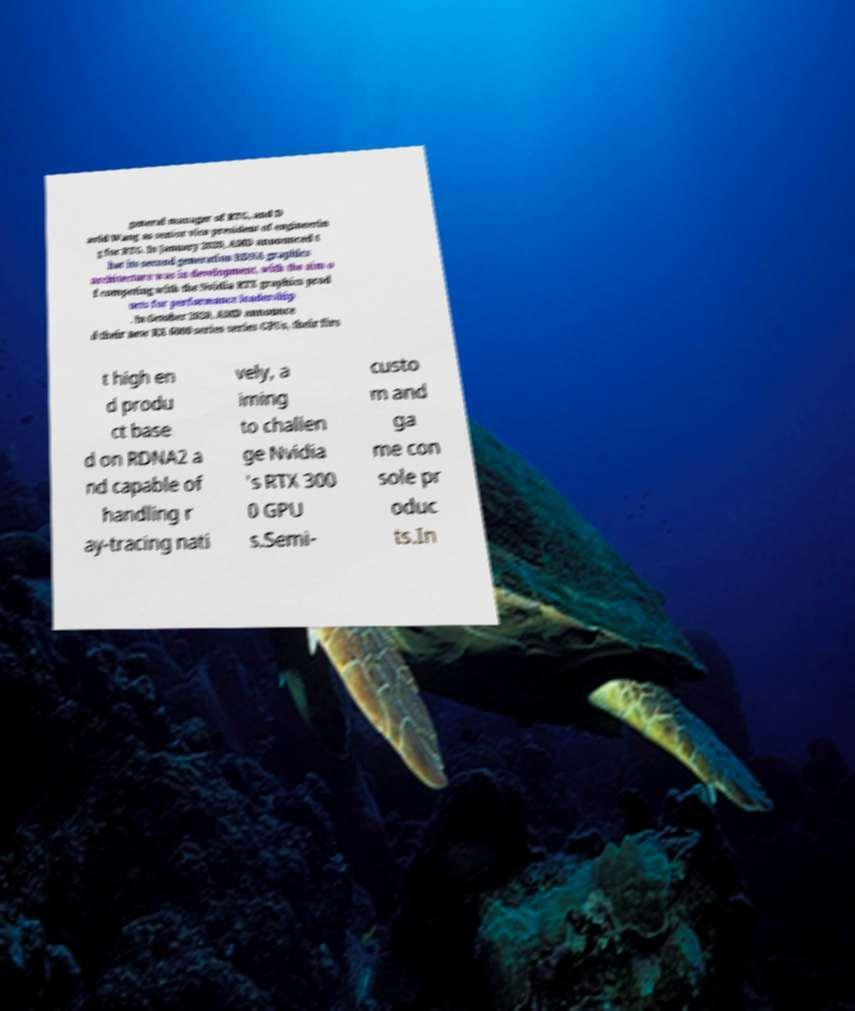Could you assist in decoding the text presented in this image and type it out clearly? general manager of RTG, and D avid Wang as senior vice president of engineerin g for RTG. In January 2020, AMD announced t hat its second generation RDNA graphics architecture was in development, with the aim o f competing with the Nvidia RTX graphics prod ucts for performance leadership . In October 2020, AMD announce d their new RX 6000 series series GPUs, their firs t high en d produ ct base d on RDNA2 a nd capable of handling r ay-tracing nati vely, a iming to challen ge Nvidia 's RTX 300 0 GPU s.Semi- custo m and ga me con sole pr oduc ts.In 